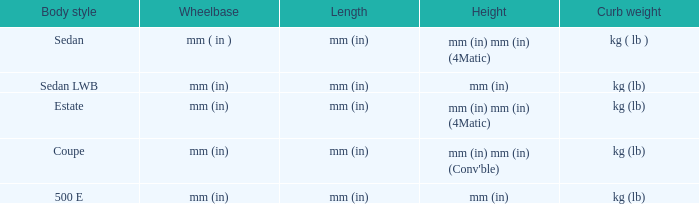What is the curb weight of the model with a wheelbase of mm (in) and elevation of mm (in) mm (in) (4matic)? Kg ( lb ), kg (lb). 